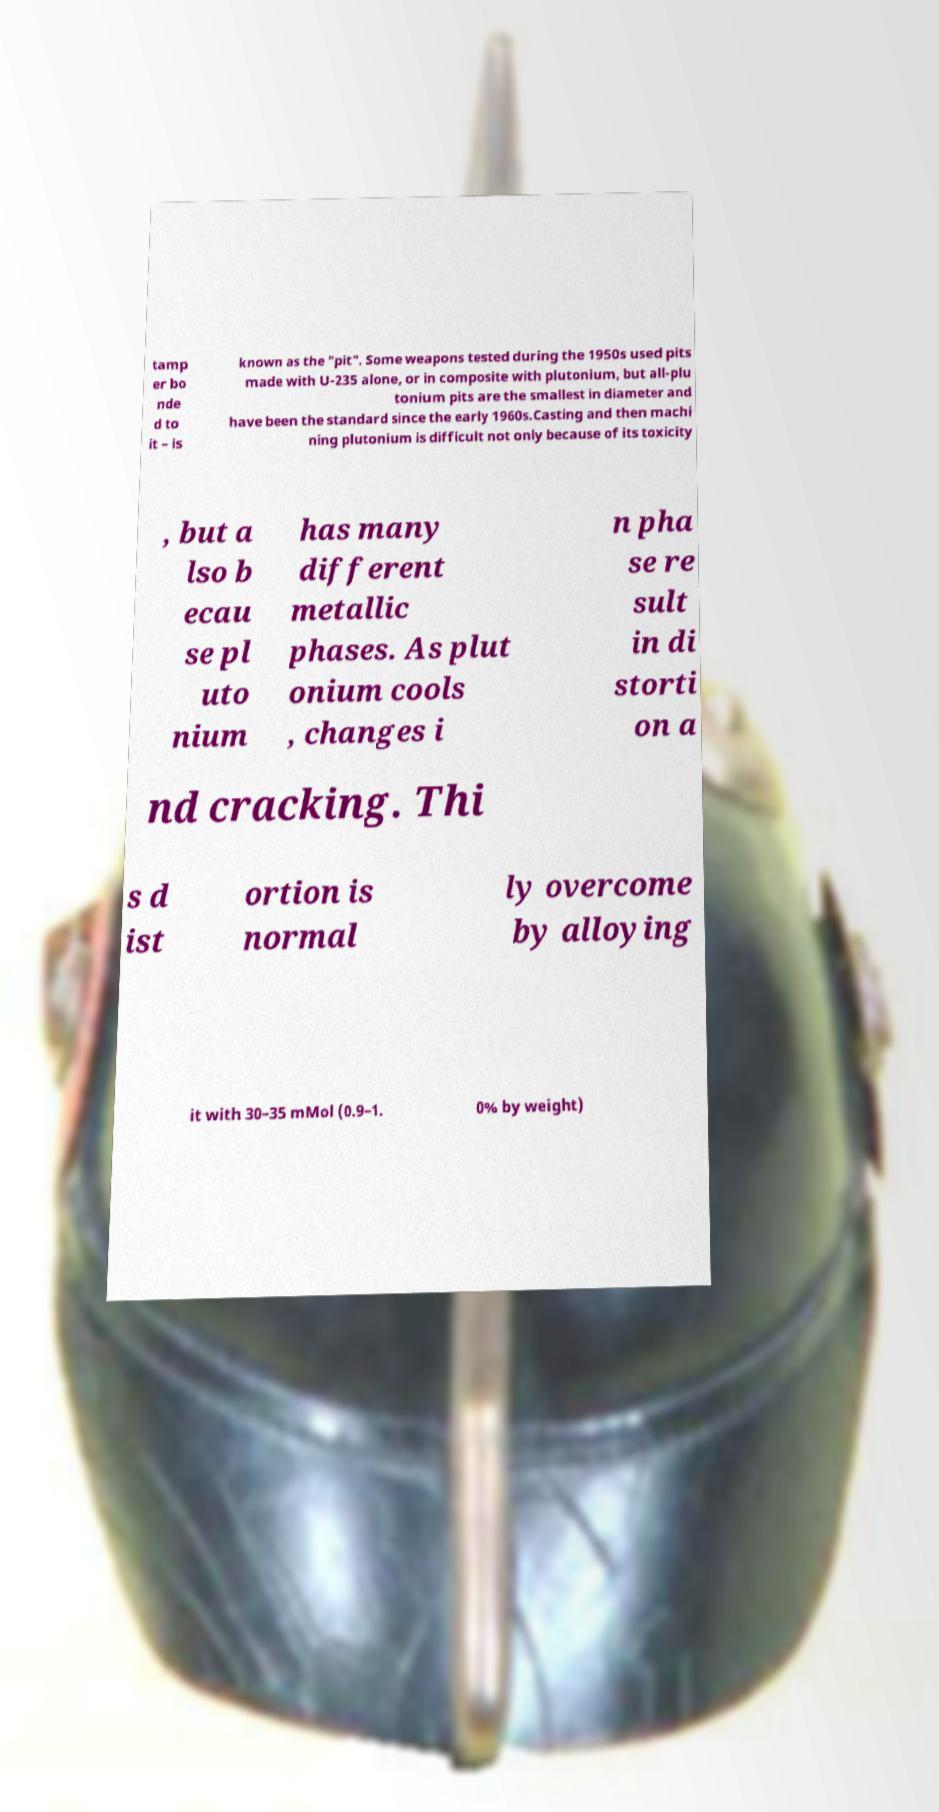Can you accurately transcribe the text from the provided image for me? tamp er bo nde d to it – is known as the "pit". Some weapons tested during the 1950s used pits made with U-235 alone, or in composite with plutonium, but all-plu tonium pits are the smallest in diameter and have been the standard since the early 1960s.Casting and then machi ning plutonium is difficult not only because of its toxicity , but a lso b ecau se pl uto nium has many different metallic phases. As plut onium cools , changes i n pha se re sult in di storti on a nd cracking. Thi s d ist ortion is normal ly overcome by alloying it with 30–35 mMol (0.9–1. 0% by weight) 